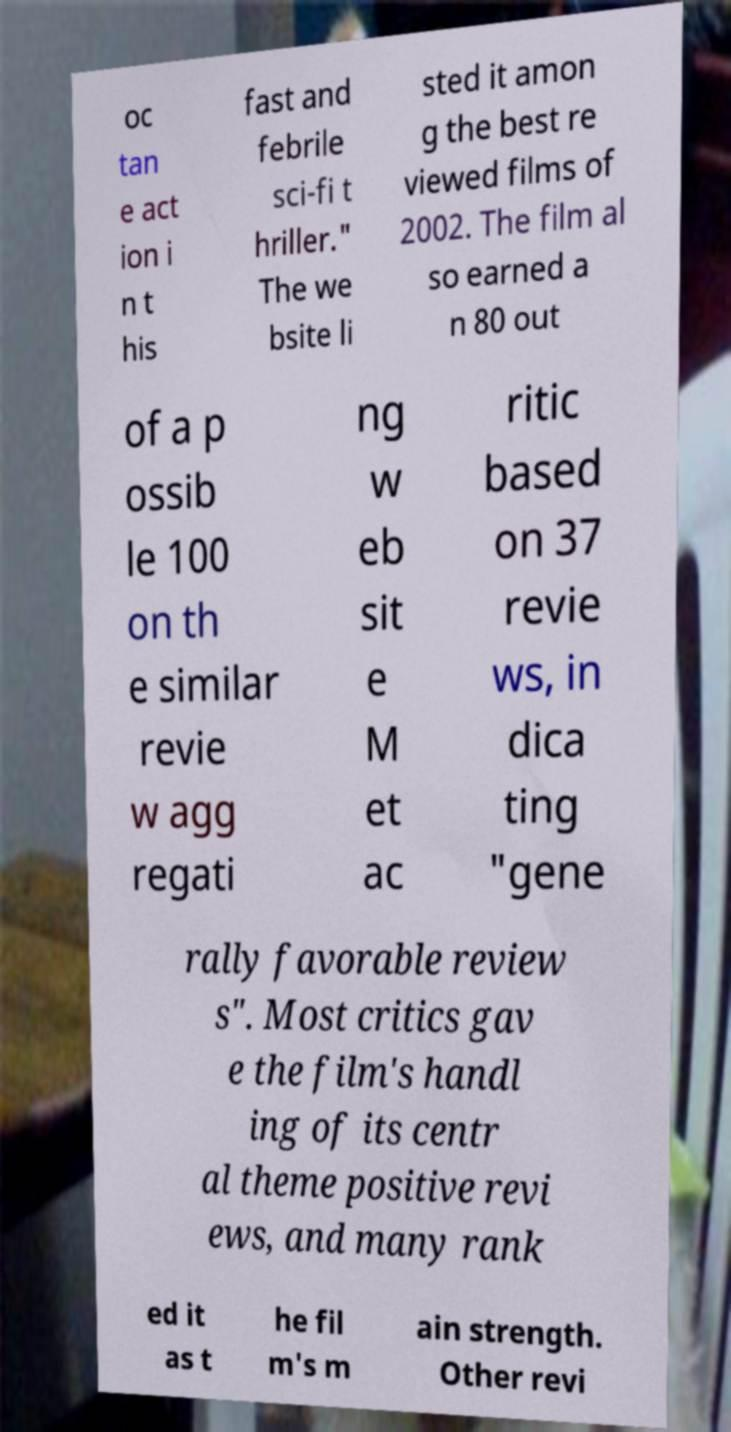Can you accurately transcribe the text from the provided image for me? oc tan e act ion i n t his fast and febrile sci-fi t hriller." The we bsite li sted it amon g the best re viewed films of 2002. The film al so earned a n 80 out of a p ossib le 100 on th e similar revie w agg regati ng w eb sit e M et ac ritic based on 37 revie ws, in dica ting "gene rally favorable review s". Most critics gav e the film's handl ing of its centr al theme positive revi ews, and many rank ed it as t he fil m's m ain strength. Other revi 